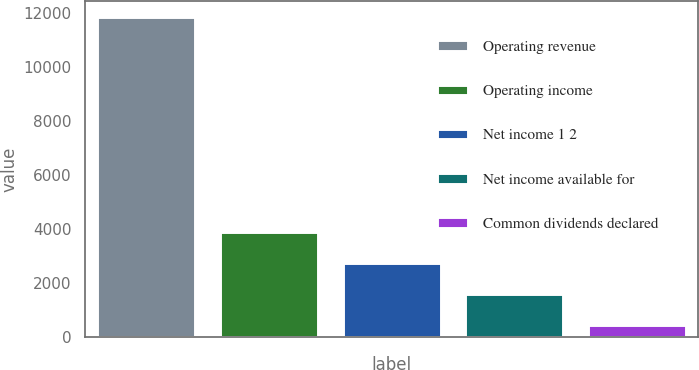<chart> <loc_0><loc_0><loc_500><loc_500><bar_chart><fcel>Operating revenue<fcel>Operating income<fcel>Net income 1 2<fcel>Net income available for<fcel>Common dividends declared<nl><fcel>11851<fcel>3883.6<fcel>2745.4<fcel>1607.2<fcel>469<nl></chart> 